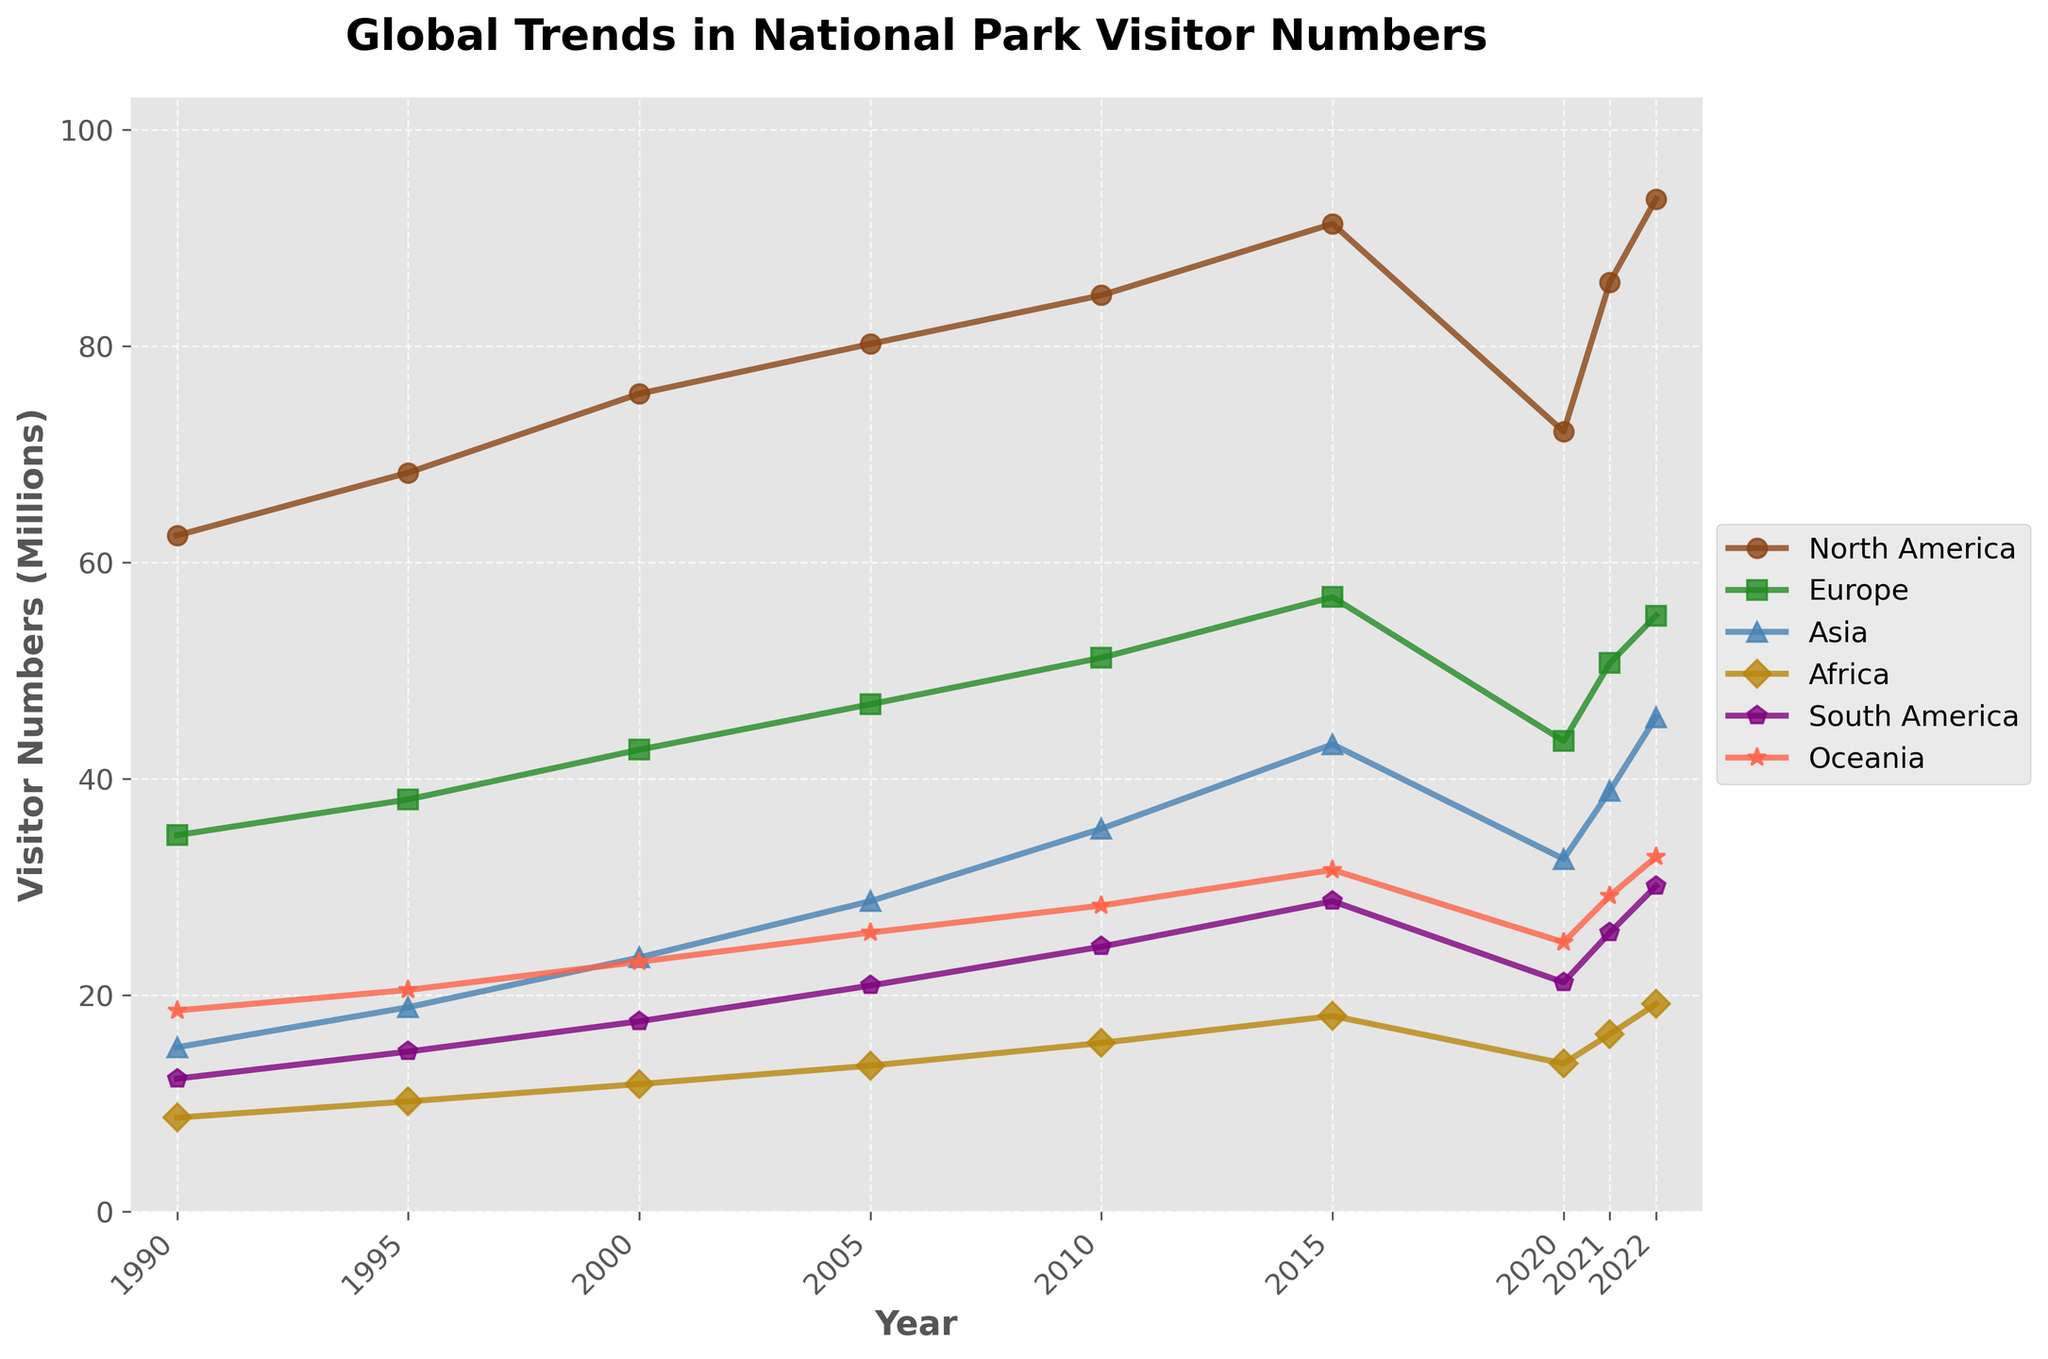What is the overall trend in visitor numbers for North America from 1990 to 2022? The line for North America starts at 62.5 million in 1990, increases steadily to 91.3 million in 2015, drops to 72.1 million in 2020, and rises again to 93.6 million in 2022. So, the overall trend is upward.
Answer: Upward Which continent had the highest visitor numbers in 2015? By examining the height of the lines for 2015, North America's line is the highest at 91.3 million.
Answer: North America In which year did Europe see a significant drop in visitor numbers? Europe shows a significant decline in visitor numbers between 2015 (56.8 million) and 2020 (43.5 million).
Answer: 2020 Compare the trend in visitor numbers between Asia and South America from 1990 to 2022. Asia's visitor numbers increased consistently from 15.2 million in 1990 to 45.7 million in 2022, while South America's increased from 12.3 million in 1990 to 30.1 million in 2022 but had less dramatic increases and decreases along the way.
Answer: Asia had a more consistent increase, South America had fluctuations In 2022, how many more visitors did Oceania have than Africa? In 2022, Oceania had 32.8 million visitors, while Africa had 19.2 million visitors. The difference is 32.8 - 19.2.
Answer: 13.6 million What was the average number of visitors for Europe between 1990 and 2022? The visitor numbers for Europe are: 34.8, 38.1, 42.7, 46.9, 51.2, 56.8, 43.5, 50.7, and 55.1. Sum these numbers and divide by the number of data points (9). (34.8 + 38.1 + 42.7 + 46.9 + 51.2 + 56.8 + 43.5 + 50.7 + 55.1) / 9 = 46.6
Answer: 46.6 million Between which consecutive years did South America experience the highest increase in visitor numbers? From the plot, the steepest slope for South America appears between 2010 (24.5 million) and 2015 (28.7 million). The increase is 28.7 - 24.5 = 4.2 million.
Answer: 2010 to 2015 Which color represents Africa in the plot? Africa is represented by the color with the fourth marker style in the legend, which is visually indicated as a golden color.
Answer: Golden In 2021, which continent had nearly the same visitor numbers as North America in 2015? In 2021, North America has 85.9 million visitors. This number is close to North America's visitor numbers in 2015, which are 91.3 million. There are no other continents with similar numbers.
Answer: North America 